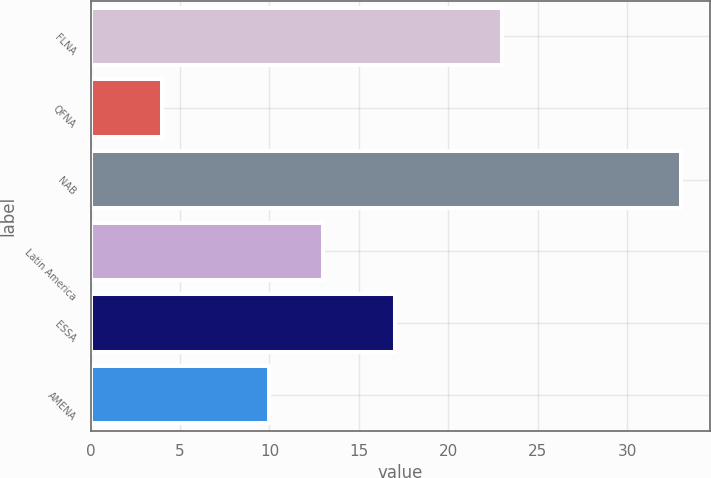Convert chart to OTSL. <chart><loc_0><loc_0><loc_500><loc_500><bar_chart><fcel>FLNA<fcel>QFNA<fcel>NAB<fcel>Latin America<fcel>ESSA<fcel>AMENA<nl><fcel>23<fcel>4<fcel>33<fcel>13<fcel>17<fcel>10<nl></chart> 